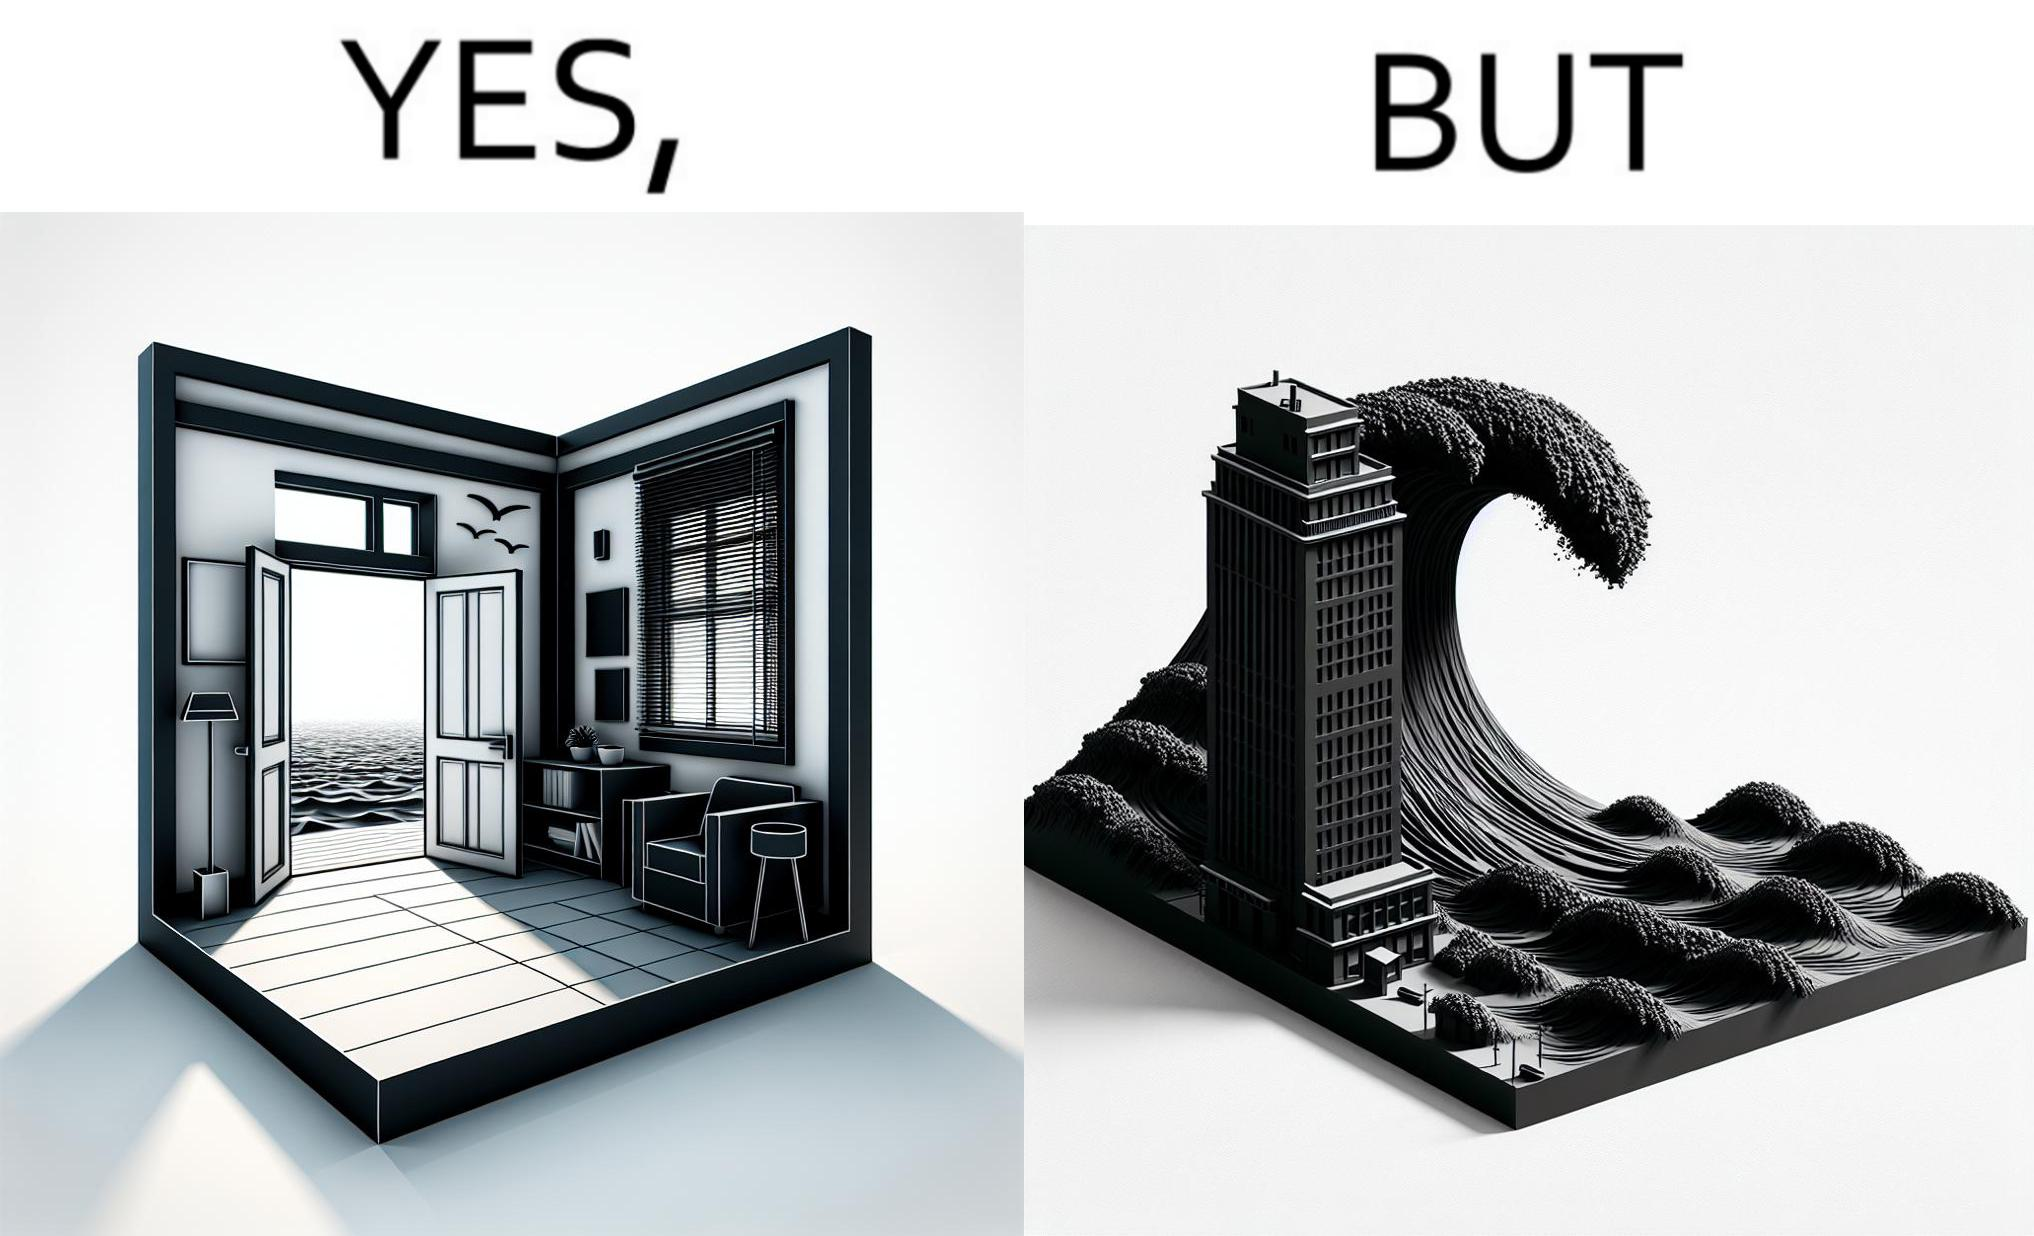What makes this image funny or satirical? The same sea which gives us a relaxation on a normal day can pose a danger to us sometimes like during a tsunami 